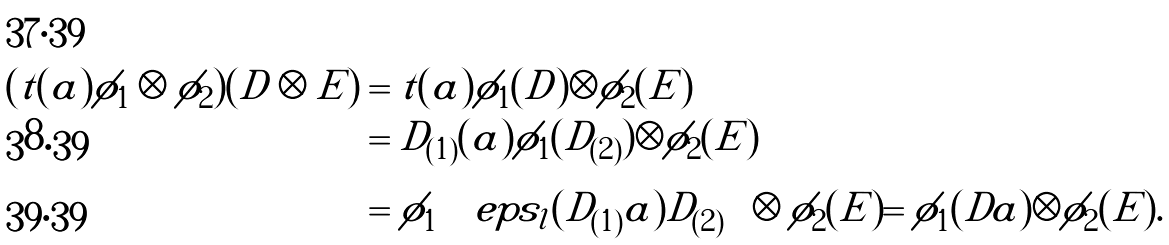<formula> <loc_0><loc_0><loc_500><loc_500>( t ( a ) \phi _ { 1 } \otimes \phi _ { 2 } ) ( D \otimes E ) & = t ( a ) \phi _ { 1 } ( D ) \otimes \phi _ { 2 } ( E ) \\ & = D _ { ( 1 ) } ( a ) \phi _ { 1 } ( D _ { ( 2 ) } ) \otimes \phi _ { 2 } ( E ) \\ & = \phi _ { 1 } \left ( \ e p s _ { l } ( D _ { ( 1 ) } a ) D _ { ( 2 ) } \right ) \otimes \phi _ { 2 } ( E ) = \phi _ { 1 } ( D a ) \otimes \phi _ { 2 } ( E ) .</formula> 